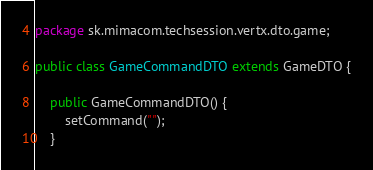Convert code to text. <code><loc_0><loc_0><loc_500><loc_500><_Java_>package sk.mimacom.techsession.vertx.dto.game;

public class GameCommandDTO extends GameDTO {

    public GameCommandDTO() {
        setCommand("");
    }
</code> 